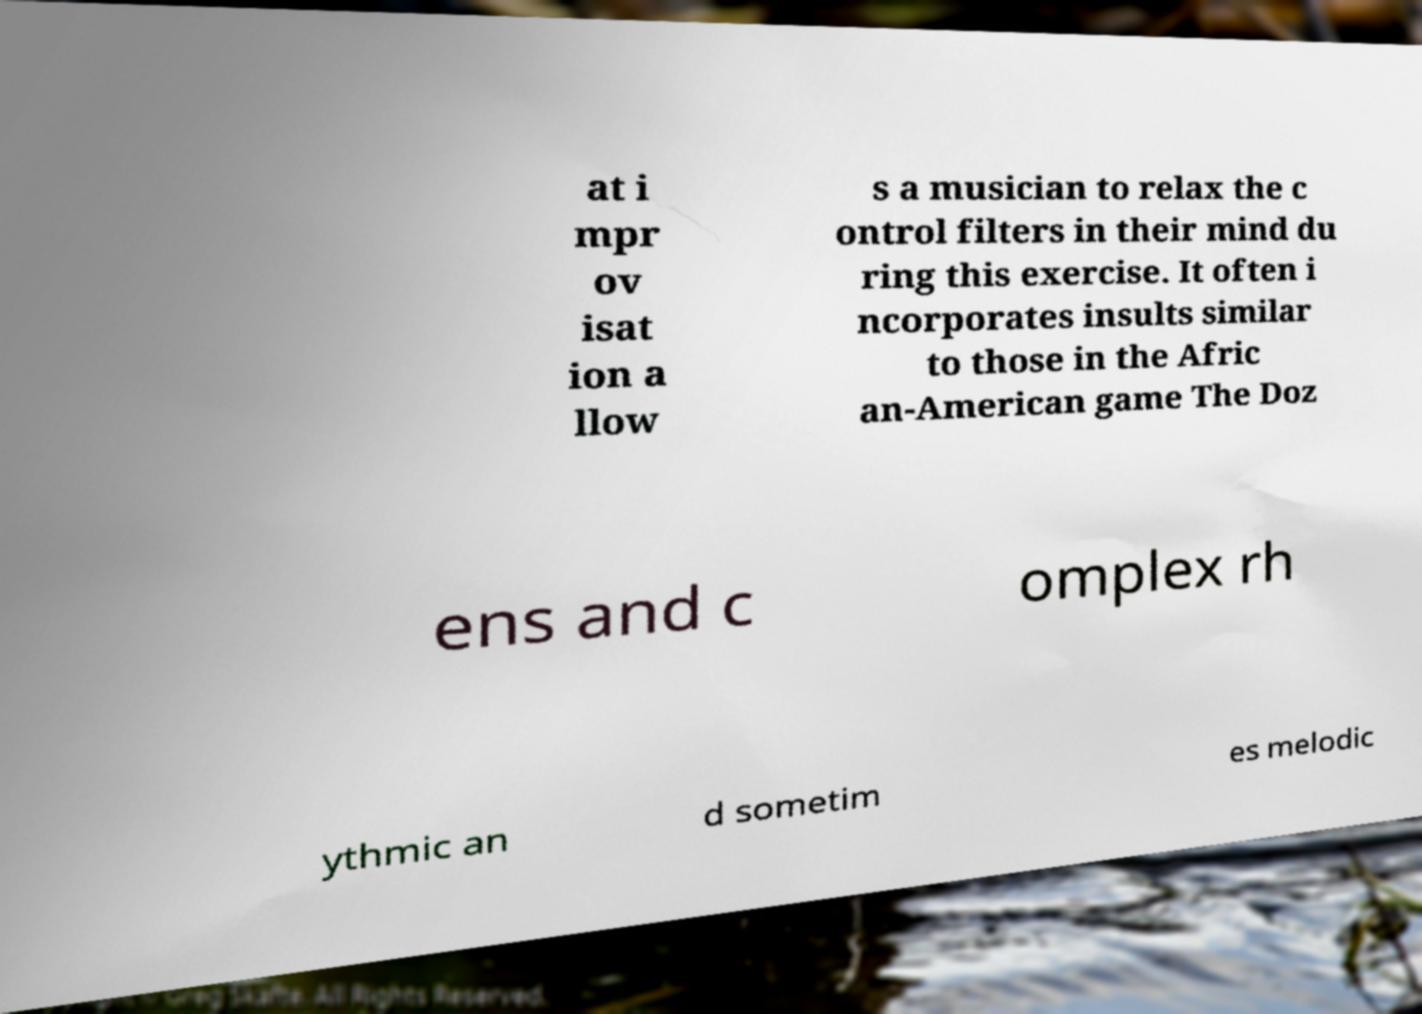For documentation purposes, I need the text within this image transcribed. Could you provide that? at i mpr ov isat ion a llow s a musician to relax the c ontrol filters in their mind du ring this exercise. It often i ncorporates insults similar to those in the Afric an-American game The Doz ens and c omplex rh ythmic an d sometim es melodic 